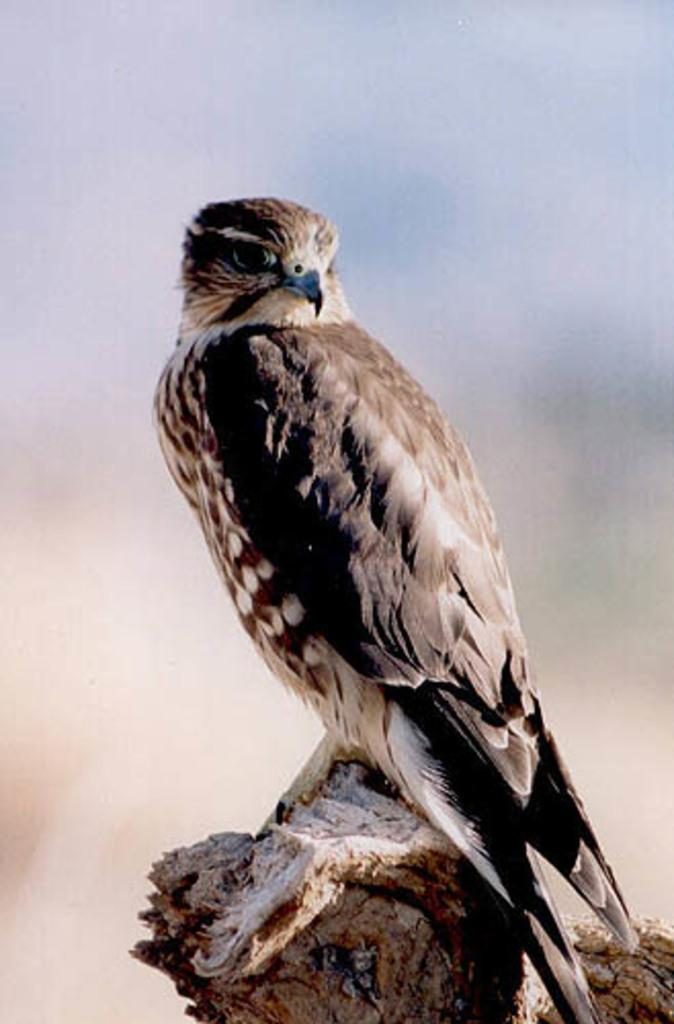What type of animal is in the image? There is a bird in the image. Can you describe the bird's coloring? The bird has brown, black, and white coloring. Where is the bird located in the image? The bird is on a wooden log. What is the color of the wooden log? The wooden log is brown in color. How would you describe the background of the image? The background of the image is blurry. Who is the expert on the rail in the image? There is no expert or rail present in the image; it features a bird on a wooden log with a blurry background. 